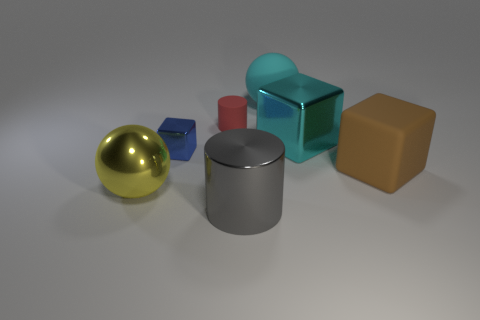Subtract all balls. How many objects are left? 5 Add 3 cyan shiny blocks. How many objects exist? 10 Subtract 0 gray spheres. How many objects are left? 7 Subtract all yellow matte things. Subtract all large cubes. How many objects are left? 5 Add 2 blue metal cubes. How many blue metal cubes are left? 3 Add 3 large balls. How many large balls exist? 5 